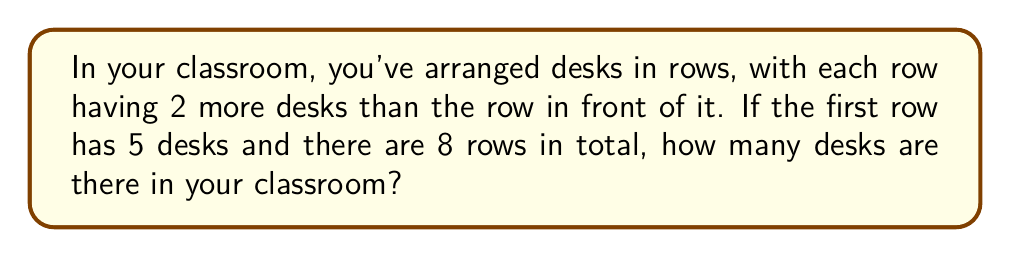Could you help me with this problem? Let's approach this step-by-step:

1) First, we identify that this is an arithmetic sequence:
   - The first term, $a_1 = 5$
   - The common difference, $d = 2$
   - The number of terms, $n = 8$

2) We can use the formula for the sum of an arithmetic sequence:
   $$ S_n = \frac{n}{2}(a_1 + a_n) $$
   where $a_n$ is the last term.

3) To find $a_n$, we can use the formula:
   $$ a_n = a_1 + (n-1)d $$

4) Let's calculate $a_8$:
   $$ a_8 = 5 + (8-1)2 = 5 + 14 = 19 $$

5) Now we can substitute into our sum formula:
   $$ S_8 = \frac{8}{2}(5 + 19) = 4(24) = 96 $$

Therefore, there are 96 desks in total in your classroom.
Answer: 96 desks 